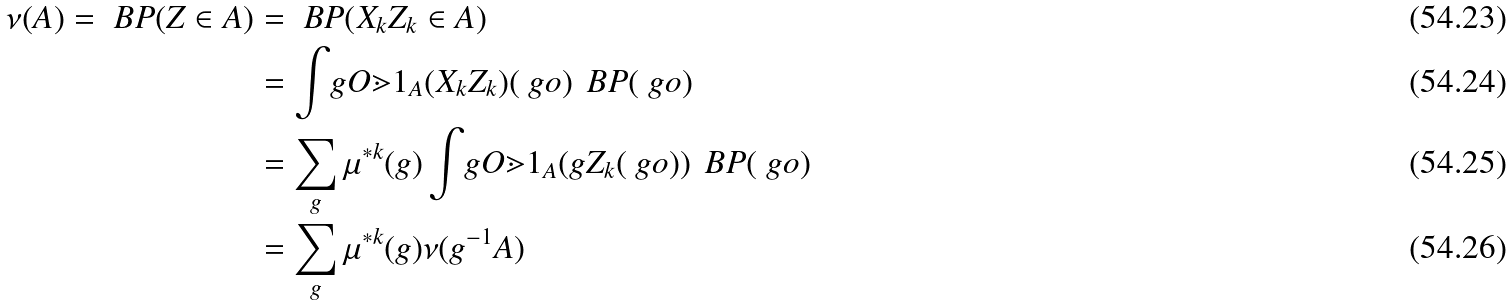Convert formula to latex. <formula><loc_0><loc_0><loc_500><loc_500>\nu ( A ) = \ B P ( Z \in A ) & = \ B P ( X _ { k } Z _ { k } \in A ) \\ & = \int _ { \ } g O \mathbb { m } { 1 } _ { A } ( X _ { k } Z _ { k } ) ( \ g o ) \, \ B P ( \ g o ) \\ & = \sum _ { g } \mu ^ { * k } ( g ) \int _ { \ } g O \mathbb { m } { 1 } _ { A } ( g Z _ { k } ( \ g o ) ) \, \ B P ( \ g o ) \\ & = \sum _ { g } \mu ^ { * k } ( g ) \nu ( g ^ { - 1 } A )</formula> 